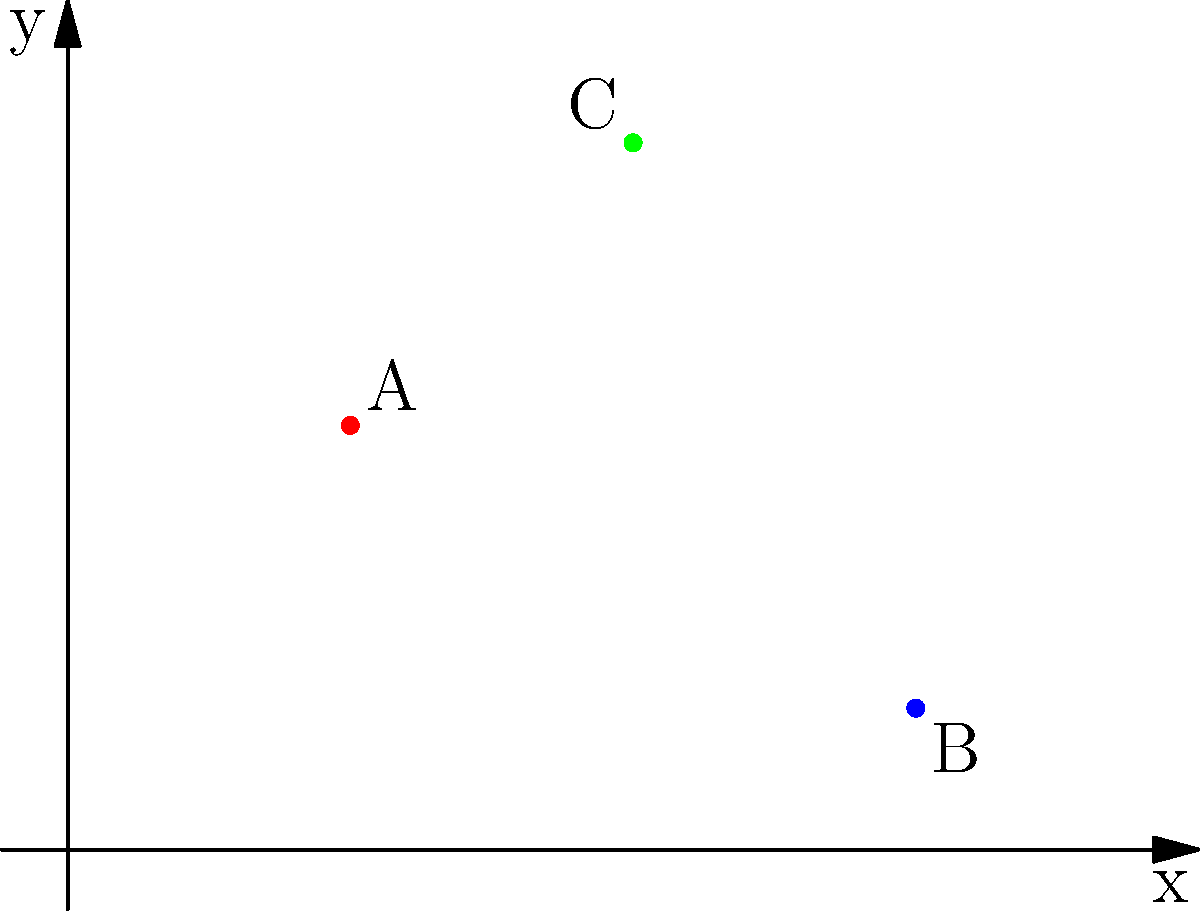In the iconic courtroom scene from "Runaway Train" (1985), Eric Roberts's character Buck is positioned at point A (2,3) on the coordinate plane. The judge is at point B (6,1), and the key piece of evidence is at point C (4,5). Calculate the area of the triangle formed by these three points to analyze the visual tension in the shot composition. To find the area of the triangle formed by these three points, we can use the formula:

Area = $\frac{1}{2}|x_1(y_2 - y_3) + x_2(y_3 - y_1) + x_3(y_1 - y_2)|$

Where $(x_1, y_1)$, $(x_2, y_2)$, and $(x_3, y_3)$ are the coordinates of the three points.

Step 1: Identify the coordinates
A (2,3), B (6,1), C (4,5)

Step 2: Plug the coordinates into the formula
Area = $\frac{1}{2}|2(1 - 5) + 6(5 - 3) + 4(3 - 1)|$

Step 3: Simplify
Area = $\frac{1}{2}|2(-4) + 6(2) + 4(2)|$
Area = $\frac{1}{2}|-8 + 12 + 8|$

Step 4: Calculate
Area = $\frac{1}{2}|12|$
Area = $\frac{1}{2}(12)$
Area = 6

The area of the triangle is 6 square units, which represents the visual tension created by the positioning of these key elements in the shot composition.
Answer: 6 square units 